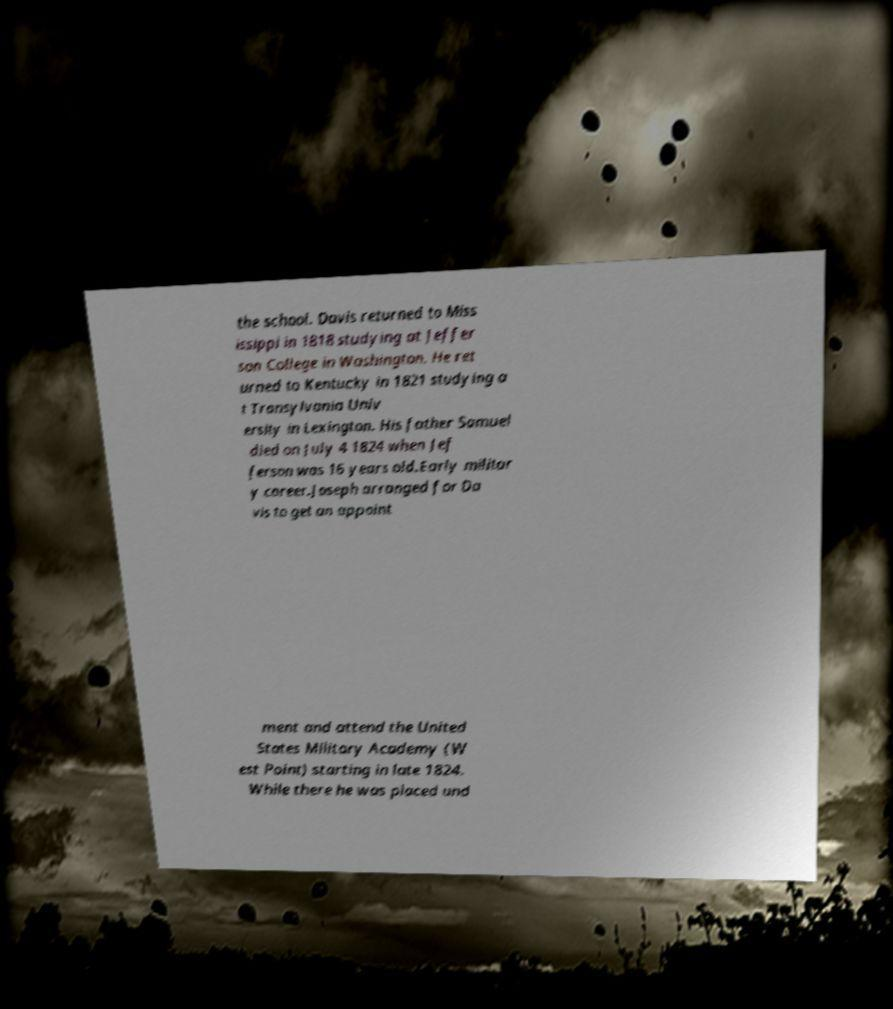What messages or text are displayed in this image? I need them in a readable, typed format. the school. Davis returned to Miss issippi in 1818 studying at Jeffer son College in Washington. He ret urned to Kentucky in 1821 studying a t Transylvania Univ ersity in Lexington. His father Samuel died on July 4 1824 when Jef ferson was 16 years old.Early militar y career.Joseph arranged for Da vis to get an appoint ment and attend the United States Military Academy (W est Point) starting in late 1824. While there he was placed und 